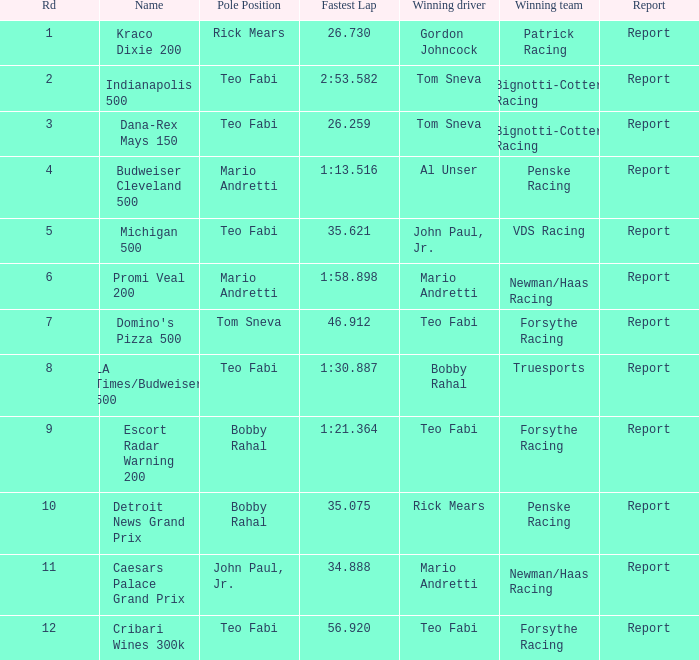Which particular rd happened at the indianapolis 500? 2.0. 